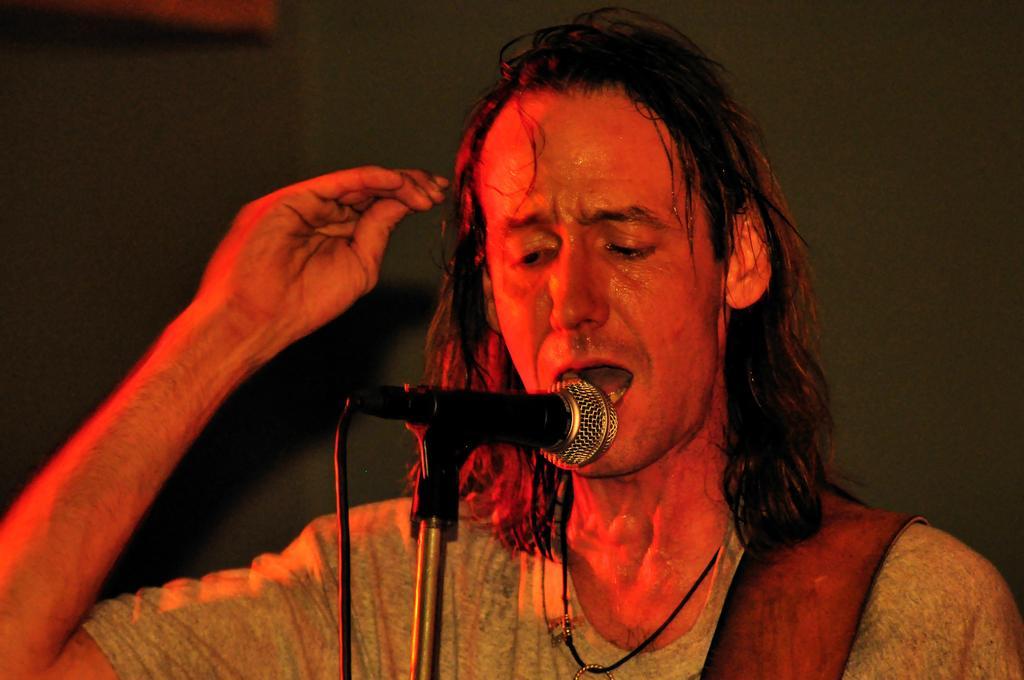How would you summarize this image in a sentence or two? In this image I can see the person with the dress and the person is in-front of the mic. I can see there is a black background. 